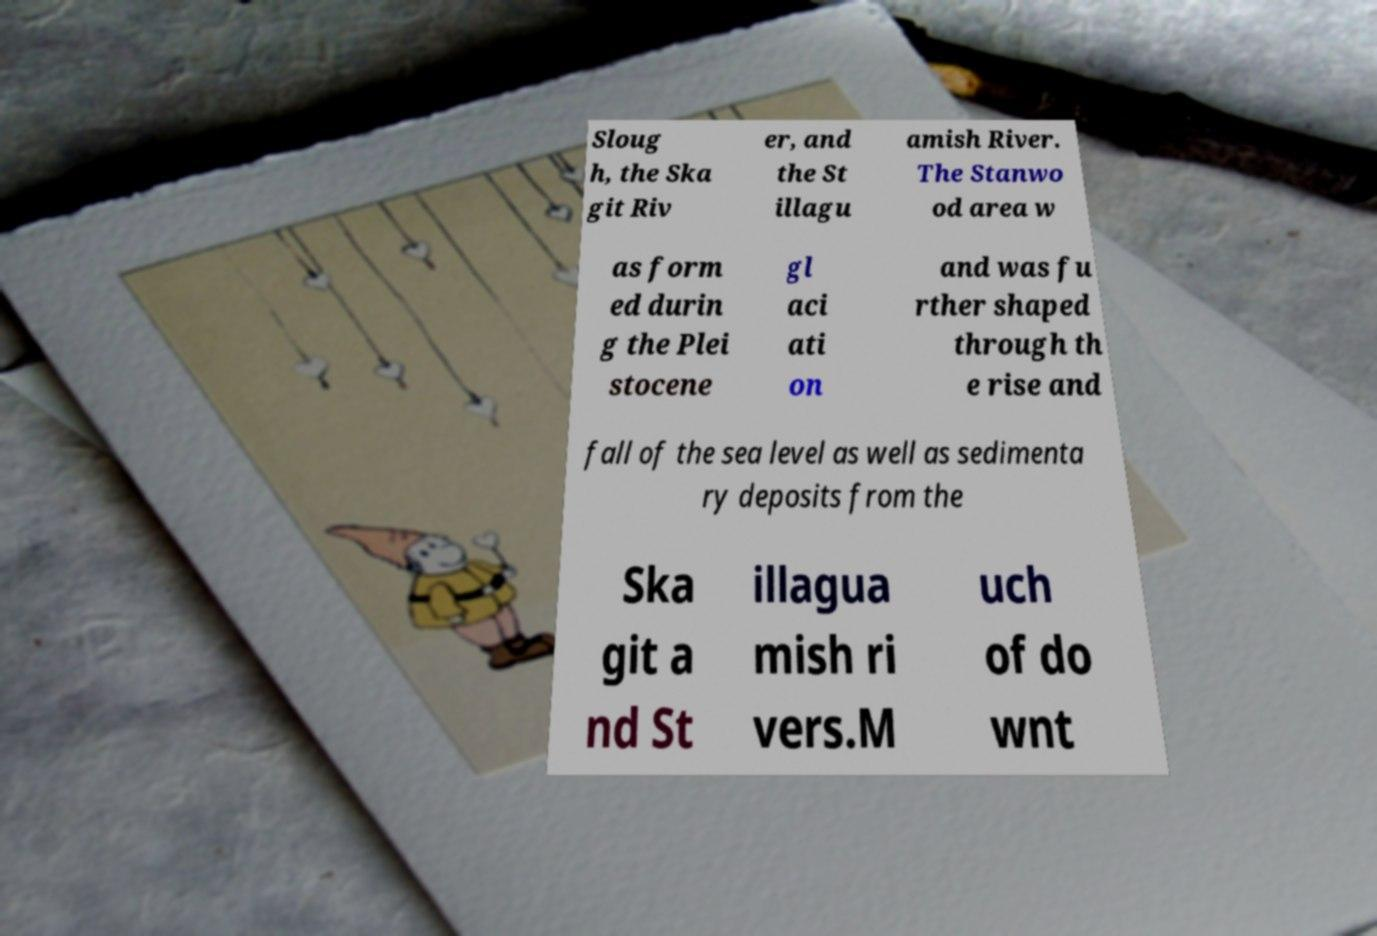Please identify and transcribe the text found in this image. Sloug h, the Ska git Riv er, and the St illagu amish River. The Stanwo od area w as form ed durin g the Plei stocene gl aci ati on and was fu rther shaped through th e rise and fall of the sea level as well as sedimenta ry deposits from the Ska git a nd St illagua mish ri vers.M uch of do wnt 